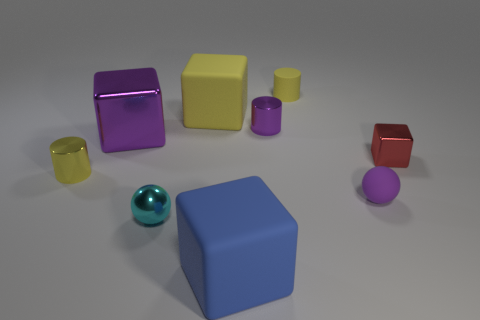Add 1 purple things. How many objects exist? 10 Subtract all cylinders. How many objects are left? 6 Subtract all purple blocks. Subtract all small blocks. How many objects are left? 7 Add 5 big objects. How many big objects are left? 8 Add 1 metallic balls. How many metallic balls exist? 2 Subtract 0 gray cylinders. How many objects are left? 9 